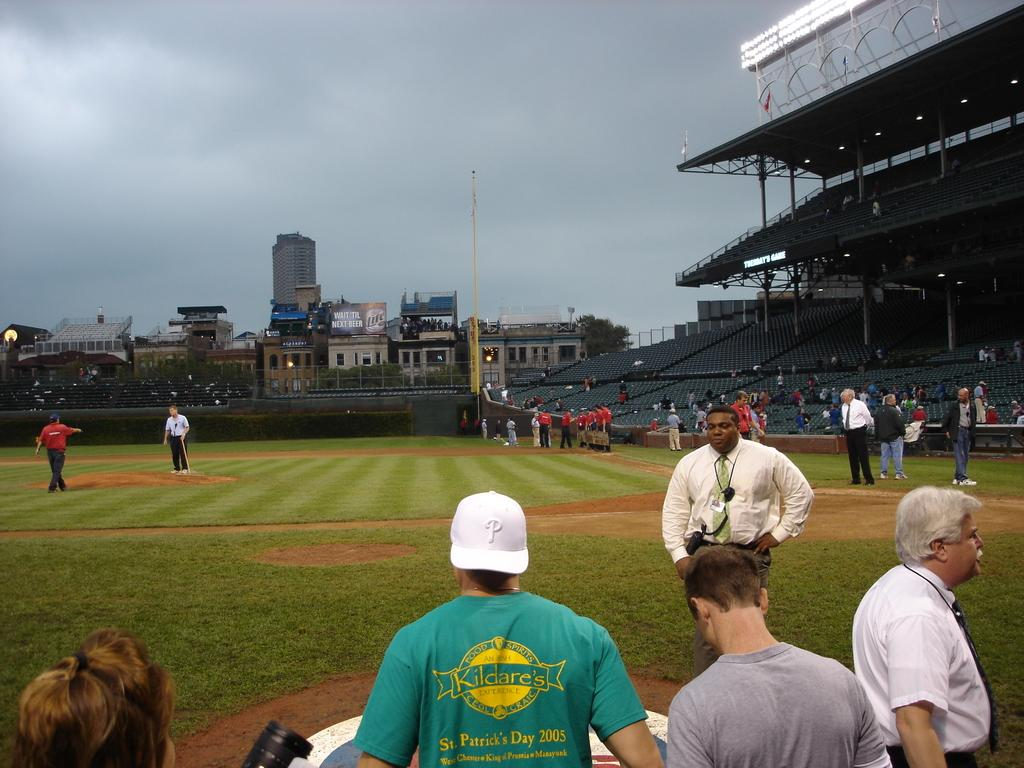<image>
Give a short and clear explanation of the subsequent image. A man wears a tee shirt with St Patrick's Day on it in yellow. 